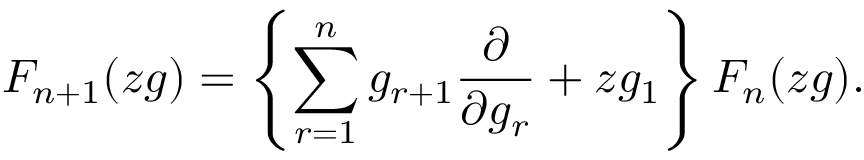<formula> <loc_0><loc_0><loc_500><loc_500>F _ { n + 1 } ( z g ) = \left \{ \sum _ { r = 1 } ^ { n } g _ { r + 1 } \frac { \partial } { \partial g _ { r } } + z g _ { 1 } \right \} F _ { n } ( z g ) .</formula> 